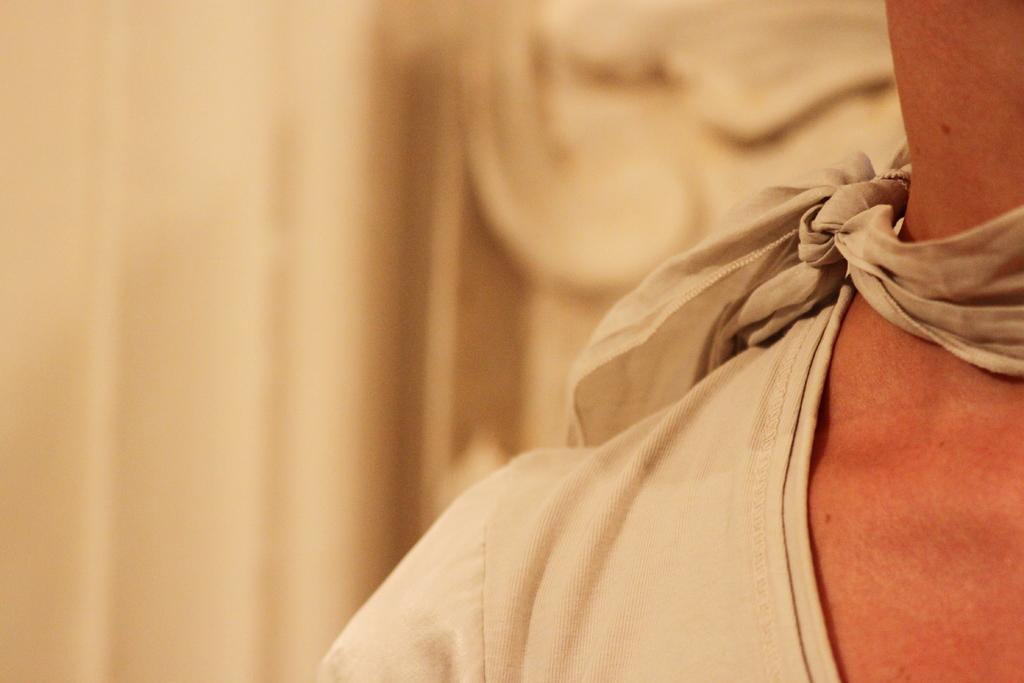What is the main subject in the image? There is a person in the image. What parts of the person are visible? The person's neck, shoulder, and clothes are visible. Can you describe the background of the image? The background of the image is blurry. How many icicles are hanging from the person's clothes in the image? There are no icicles present in the image. What type of cake is being served to the person in the image? There is no cake present in the image. 